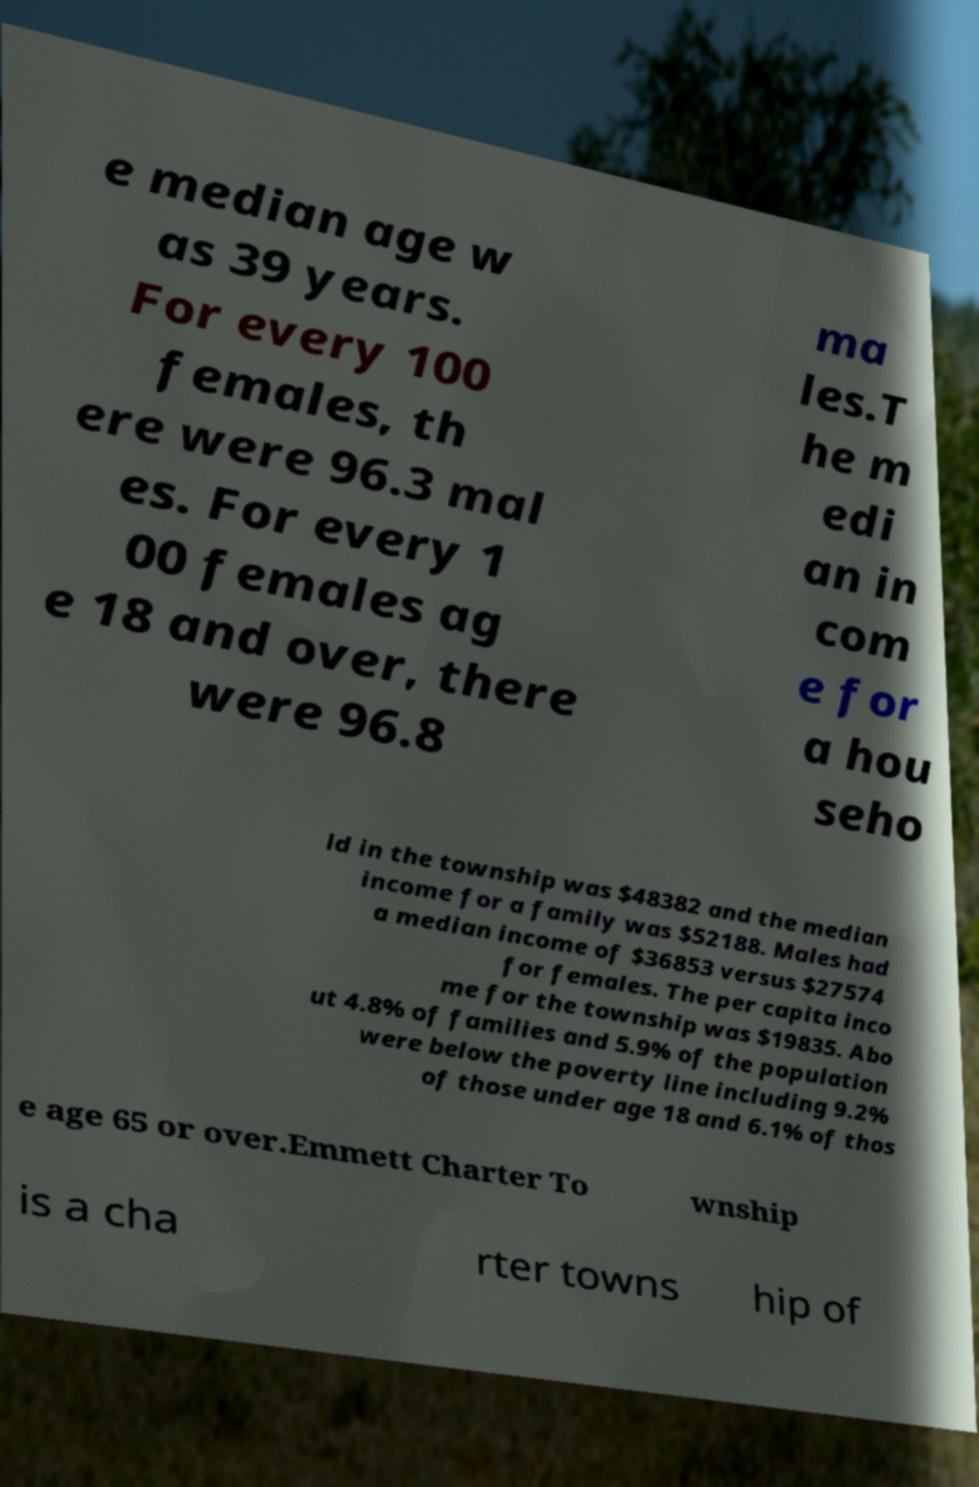What messages or text are displayed in this image? I need them in a readable, typed format. e median age w as 39 years. For every 100 females, th ere were 96.3 mal es. For every 1 00 females ag e 18 and over, there were 96.8 ma les.T he m edi an in com e for a hou seho ld in the township was $48382 and the median income for a family was $52188. Males had a median income of $36853 versus $27574 for females. The per capita inco me for the township was $19835. Abo ut 4.8% of families and 5.9% of the population were below the poverty line including 9.2% of those under age 18 and 6.1% of thos e age 65 or over.Emmett Charter To wnship is a cha rter towns hip of 